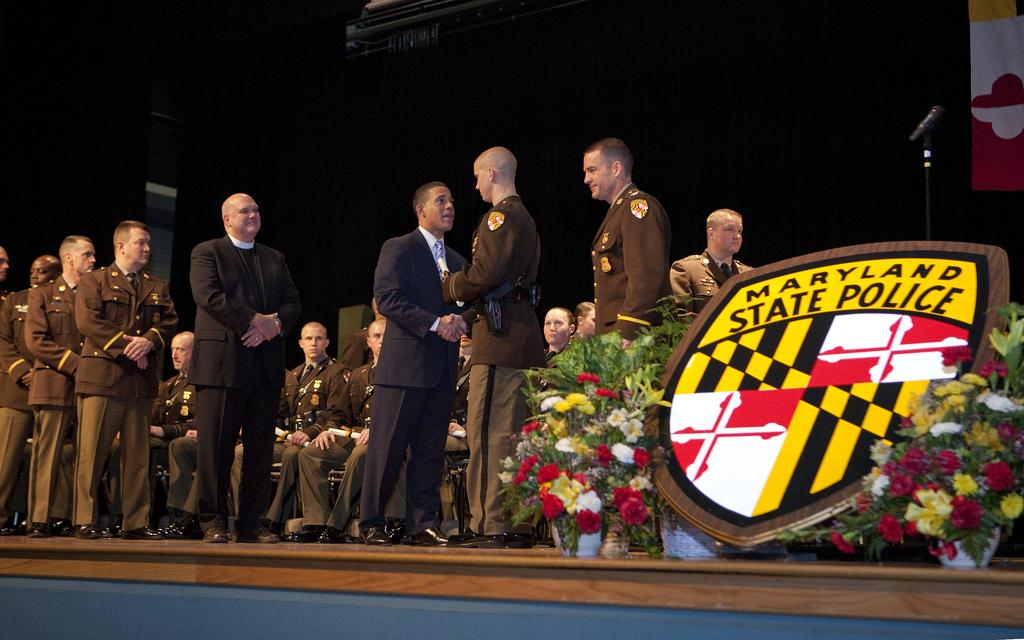What can be seen in the image involving multiple individuals? There is a group of people in the image. What type of flora is present in the image? There are flowers in the image. What object is visible that is commonly used for amplifying sound? There is a microphone (mic) in the image. What type of horn can be seen in the image? There is no horn present in the image. How does the sun appear in the image? The image does not show the sun; it only features a group of people, flowers, and a microphone. Can you describe the grandmother in the image? There is no mention of a grandmother in the provided facts, so we cannot describe her in the image. 